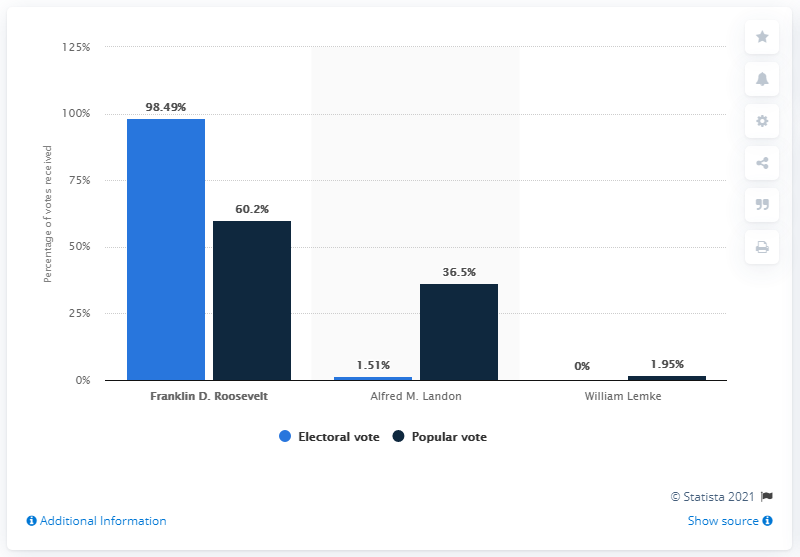Mention a couple of crucial points in this snapshot. In 1936, Alfred M. Landon was the Democratic presidential candidate. 